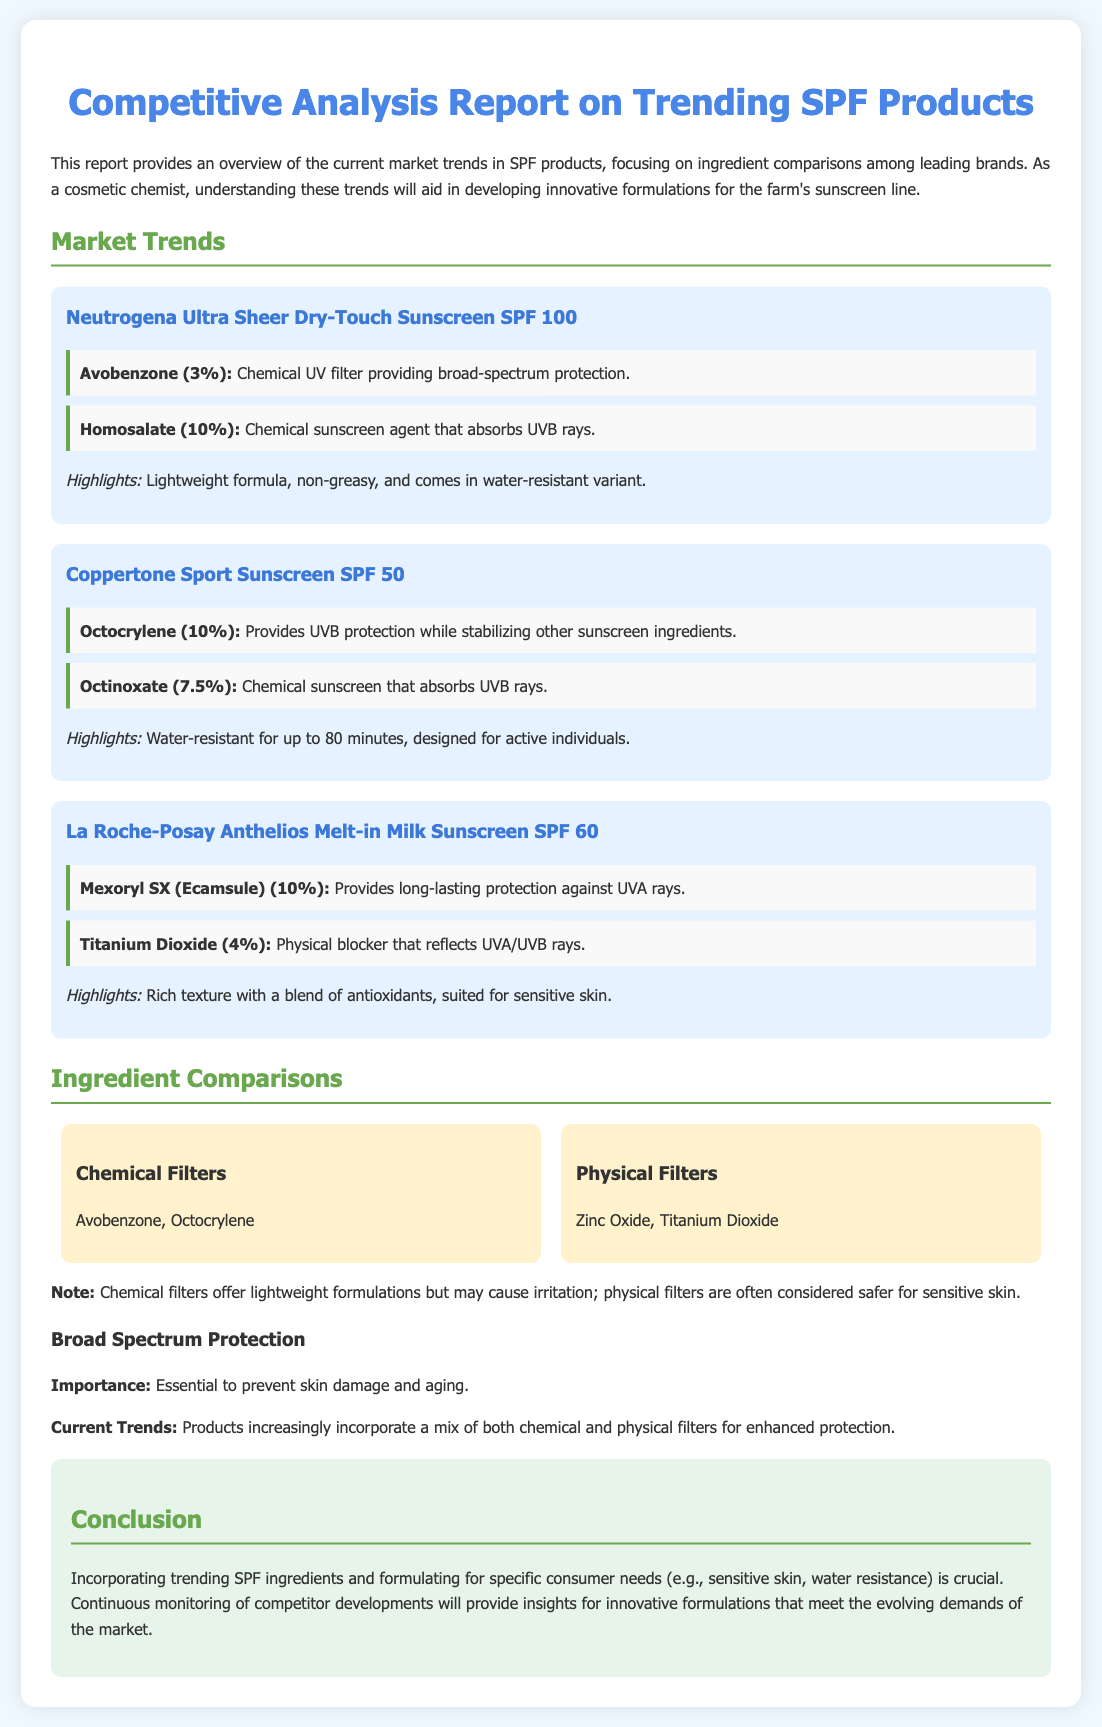what is the SPF of Neutrogena Ultra Sheer Dry-Touch Sunscreen? Neutrogena Ultra Sheer Dry-Touch Sunscreen has an SPF value of 100.
Answer: SPF 100 which ingredient in Coppertone Sport Sunscreen provides UVB protection? Octocrylene in Coppertone Sport Sunscreen provides UVB protection.
Answer: Octocrylene how long is Coppertone Sport Sunscreen water-resistant? Coppertone Sport Sunscreen is water-resistant for up to 80 minutes.
Answer: 80 minutes what type of protection does Mexoryl SX provide? Mexoryl SX provides long-lasting protection against UVA rays.
Answer: UVA rays which ingredient serves as a physical blocker in La Roche-Posay Anthelios Melt-in Milk Sunscreen? Titanium Dioxide serves as a physical blocker in La Roche-Posay Anthelios Melt-in Milk Sunscreen.
Answer: Titanium Dioxide what is the essential role of broad spectrum protection? The essential role of broad spectrum protection is to prevent skin damage and aging.
Answer: prevent skin damage and aging what are the two categories of chemical filters mentioned? The two categories of chemical filters mentioned are Avobenzone and Octocrylene.
Answer: Avobenzone, Octocrylene what is highlighted as crucial for innovative formulation development? Incorporating trending SPF ingredients and formulating for specific consumer needs is crucial for innovative formulation development.
Answer: Incorporating trending SPF ingredients and formulating for specific consumer needs how many products are analyzed in this report? The report analyzes three products.
Answer: three products 